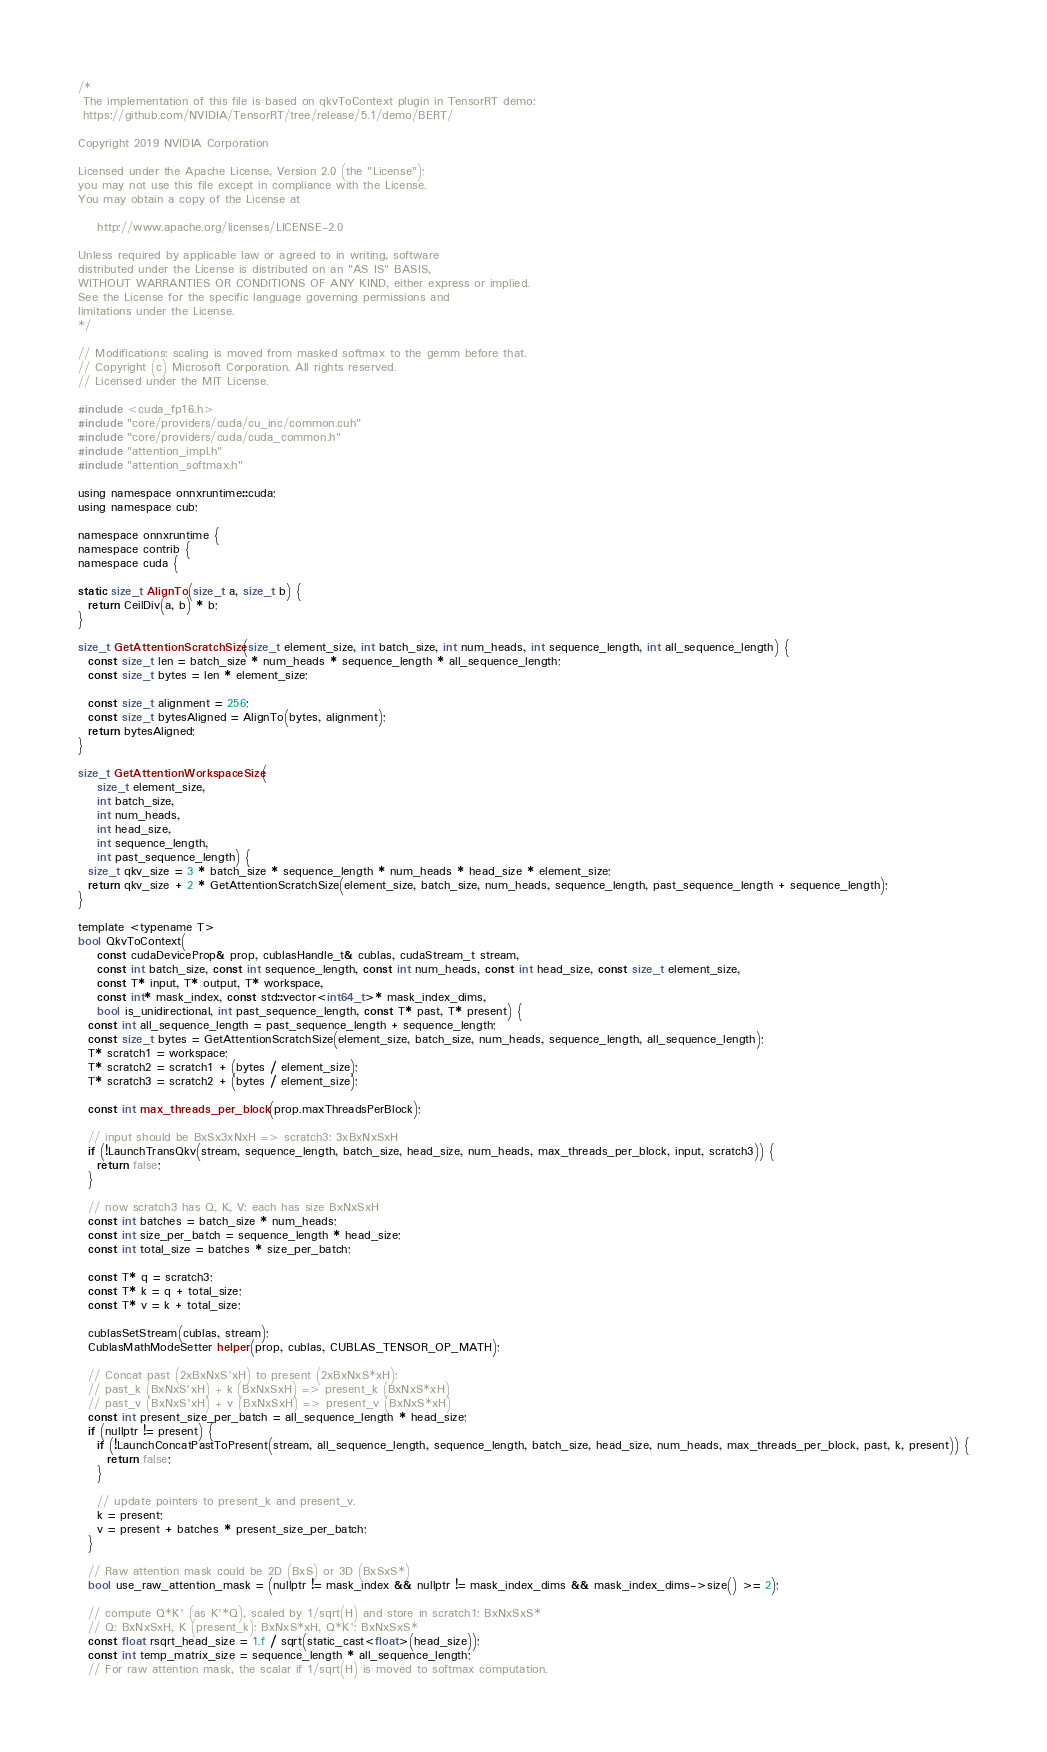<code> <loc_0><loc_0><loc_500><loc_500><_Cuda_>/*
 The implementation of this file is based on qkvToContext plugin in TensorRT demo:
 https://github.com/NVIDIA/TensorRT/tree/release/5.1/demo/BERT/

Copyright 2019 NVIDIA Corporation

Licensed under the Apache License, Version 2.0 (the "License");
you may not use this file except in compliance with the License.
You may obtain a copy of the License at

    http://www.apache.org/licenses/LICENSE-2.0

Unless required by applicable law or agreed to in writing, software
distributed under the License is distributed on an "AS IS" BASIS,
WITHOUT WARRANTIES OR CONDITIONS OF ANY KIND, either express or implied.
See the License for the specific language governing permissions and
limitations under the License.
*/

// Modifications: scaling is moved from masked softmax to the gemm before that.
// Copyright (c) Microsoft Corporation. All rights reserved.
// Licensed under the MIT License.

#include <cuda_fp16.h>
#include "core/providers/cuda/cu_inc/common.cuh"
#include "core/providers/cuda/cuda_common.h"
#include "attention_impl.h"
#include "attention_softmax.h"

using namespace onnxruntime::cuda;
using namespace cub;

namespace onnxruntime {
namespace contrib {
namespace cuda {

static size_t AlignTo(size_t a, size_t b) {
  return CeilDiv(a, b) * b;
}

size_t GetAttentionScratchSize(size_t element_size, int batch_size, int num_heads, int sequence_length, int all_sequence_length) {
  const size_t len = batch_size * num_heads * sequence_length * all_sequence_length;
  const size_t bytes = len * element_size;

  const size_t alignment = 256;
  const size_t bytesAligned = AlignTo(bytes, alignment);
  return bytesAligned;
}

size_t GetAttentionWorkspaceSize(
    size_t element_size,
    int batch_size,
    int num_heads,
    int head_size,
    int sequence_length,
    int past_sequence_length) {
  size_t qkv_size = 3 * batch_size * sequence_length * num_heads * head_size * element_size;
  return qkv_size + 2 * GetAttentionScratchSize(element_size, batch_size, num_heads, sequence_length, past_sequence_length + sequence_length);
}

template <typename T>
bool QkvToContext(
    const cudaDeviceProp& prop, cublasHandle_t& cublas, cudaStream_t stream,
    const int batch_size, const int sequence_length, const int num_heads, const int head_size, const size_t element_size,
    const T* input, T* output, T* workspace,
    const int* mask_index, const std::vector<int64_t>* mask_index_dims,
    bool is_unidirectional, int past_sequence_length, const T* past, T* present) {
  const int all_sequence_length = past_sequence_length + sequence_length;
  const size_t bytes = GetAttentionScratchSize(element_size, batch_size, num_heads, sequence_length, all_sequence_length);
  T* scratch1 = workspace;
  T* scratch2 = scratch1 + (bytes / element_size);
  T* scratch3 = scratch2 + (bytes / element_size);

  const int max_threads_per_block(prop.maxThreadsPerBlock);

  // input should be BxSx3xNxH => scratch3: 3xBxNxSxH
  if (!LaunchTransQkv(stream, sequence_length, batch_size, head_size, num_heads, max_threads_per_block, input, scratch3)) {
    return false;
  }

  // now scratch3 has Q, K, V: each has size BxNxSxH
  const int batches = batch_size * num_heads;
  const int size_per_batch = sequence_length * head_size;
  const int total_size = batches * size_per_batch;

  const T* q = scratch3;
  const T* k = q + total_size;
  const T* v = k + total_size;

  cublasSetStream(cublas, stream);
  CublasMathModeSetter helper(prop, cublas, CUBLAS_TENSOR_OP_MATH);

  // Concat past (2xBxNxS'xH) to present (2xBxNxS*xH):
  // past_k (BxNxS'xH) + k (BxNxSxH) => present_k (BxNxS*xH)
  // past_v (BxNxS'xH) + v (BxNxSxH) => present_v (BxNxS*xH)
  const int present_size_per_batch = all_sequence_length * head_size;
  if (nullptr != present) {
    if (!LaunchConcatPastToPresent(stream, all_sequence_length, sequence_length, batch_size, head_size, num_heads, max_threads_per_block, past, k, present)) {
      return false;
    }

    // update pointers to present_k and present_v.
    k = present;
    v = present + batches * present_size_per_batch;
  }

  // Raw attention mask could be 2D (BxS) or 3D (BxSxS*)
  bool use_raw_attention_mask = (nullptr != mask_index && nullptr != mask_index_dims && mask_index_dims->size() >= 2);

  // compute Q*K' (as K'*Q), scaled by 1/sqrt(H) and store in scratch1: BxNxSxS*
  // Q: BxNxSxH, K (present_k): BxNxS*xH, Q*K': BxNxSxS*
  const float rsqrt_head_size = 1.f / sqrt(static_cast<float>(head_size));
  const int temp_matrix_size = sequence_length * all_sequence_length;
  // For raw attention mask, the scalar if 1/sqrt(H) is moved to softmax computation.</code> 